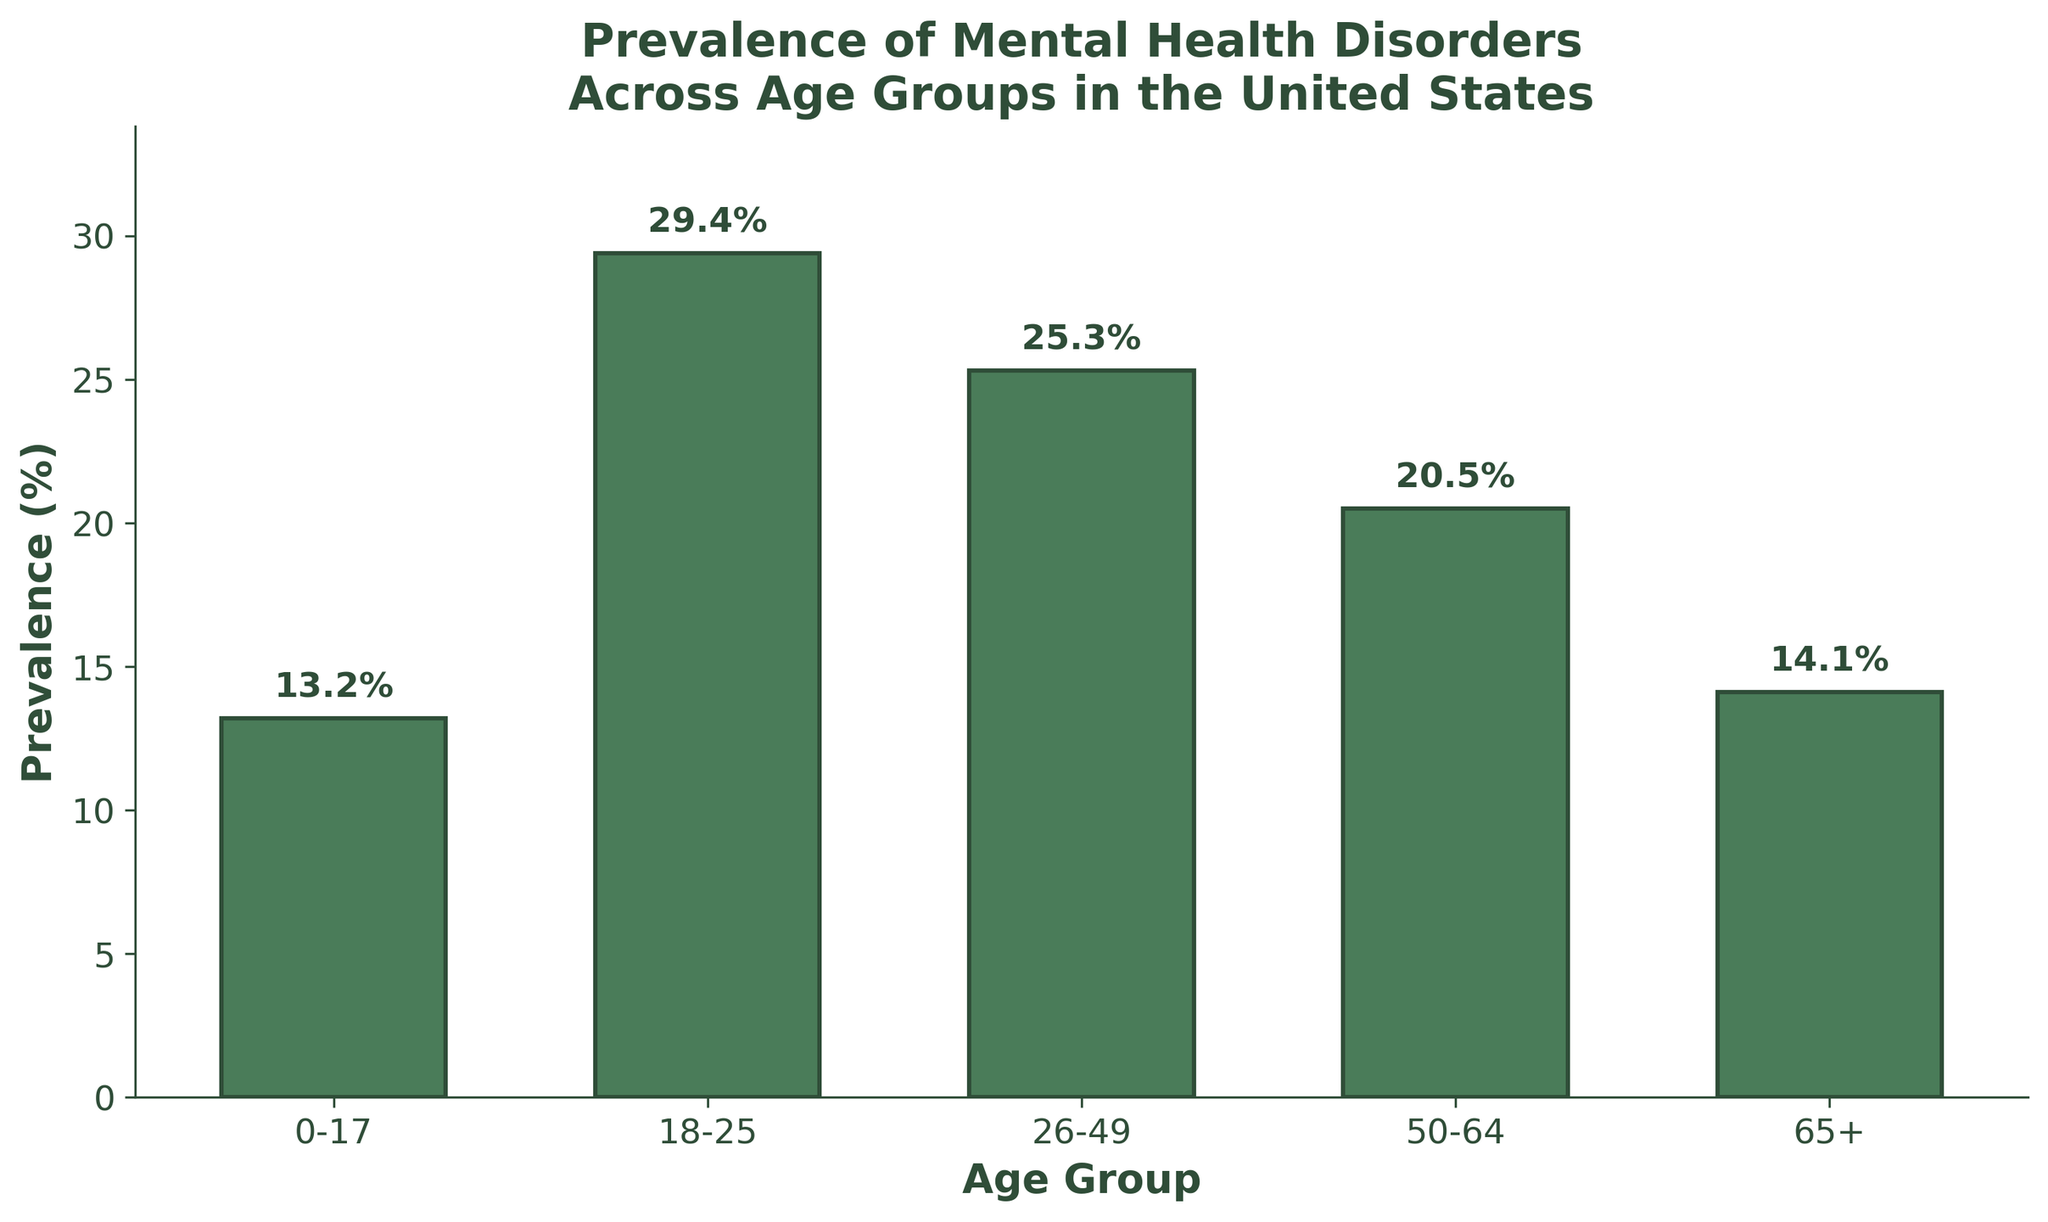Which age group has the highest prevalence of mental health disorders? The bar for the 18-25 age group is the tallest, with a prevalence of 29.4%.
Answer: 18-25 Which age group has the lowest prevalence of mental health disorders? The bar for the 0-17 age group is the shortest, with a prevalence of 13.2%.
Answer: 0-17 What is the difference in prevalence between the 18-25 and 65+ age groups? The prevalence for 18-25 is 29.4%, and for 65+ it is 14.1%. The difference is 29.4 - 14.1 = 15.3%.
Answer: 15.3% Which age groups have a prevalence higher than 20%? The bars for the 18-25, 26-49, and 50-64 age groups are higher than the 20% mark.
Answer: 18-25, 26-49, 50-64 What is the combined prevalence for age groups 0-17 and 65+? The prevalence for 0-17 is 13.2%, and for 65+ it is 14.1%. The combined prevalence is 13.2 + 14.1 = 27.3%.
Answer: 27.3% Which pair of age groups has the smallest difference in prevalence? The smallest difference is between the 0-17 (13.2%) and 65+ (14.1%) age groups, with a difference of 14.1 - 13.2 = 0.9%.
Answer: 0-17 and 65+ Rank the age groups from highest to lowest prevalence. From highest to lowest prevalence: 18-25 (29.4%), 26-49 (25.3%), 50-64 (20.5%), 65+ (14.1%), 0-17 (13.2%).
Answer: 18-25, 26-49, 50-64, 65+, 0-17 What is the average prevalence across all age groups? Sum the prevalence values: 13.2 + 29.4 + 25.3 + 20.5 + 14.1 = 102.5. Divide by the number of age groups: 102.5 / 5 = 20.5%.
Answer: 20.5% By how much does the prevalence in the 18-25 age group exceed the overall average prevalence? The overall average prevalence is 20.5%. The 18-25 age group's prevalence is 29.4%. The difference is 29.4 - 20.5 = 8.9%.
Answer: 8.9% Which age group between 26-49 and 50-64 has a higher prevalence? The bar for the 26-49 age group is taller, with a prevalence of 25.3%, compared to 50-64, which is 20.5%.
Answer: 26-49 